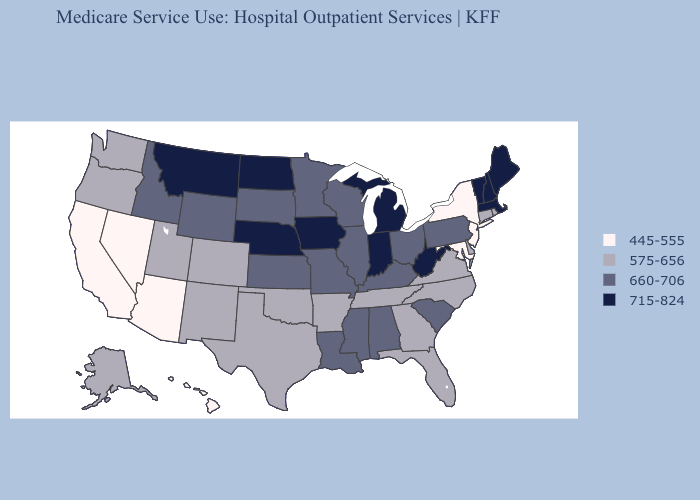Does Wyoming have the highest value in the USA?
Write a very short answer. No. Name the states that have a value in the range 575-656?
Quick response, please. Alaska, Arkansas, Colorado, Connecticut, Delaware, Florida, Georgia, New Mexico, North Carolina, Oklahoma, Oregon, Rhode Island, Tennessee, Texas, Utah, Virginia, Washington. Does West Virginia have the highest value in the South?
Concise answer only. Yes. What is the value of Utah?
Write a very short answer. 575-656. What is the value of Vermont?
Keep it brief. 715-824. Among the states that border Washington , which have the highest value?
Answer briefly. Idaho. What is the value of Wisconsin?
Be succinct. 660-706. What is the lowest value in states that border West Virginia?
Write a very short answer. 445-555. Name the states that have a value in the range 660-706?
Give a very brief answer. Alabama, Idaho, Illinois, Kansas, Kentucky, Louisiana, Minnesota, Mississippi, Missouri, Ohio, Pennsylvania, South Carolina, South Dakota, Wisconsin, Wyoming. Among the states that border Vermont , which have the lowest value?
Give a very brief answer. New York. Which states have the lowest value in the West?
Quick response, please. Arizona, California, Hawaii, Nevada. Name the states that have a value in the range 715-824?
Give a very brief answer. Indiana, Iowa, Maine, Massachusetts, Michigan, Montana, Nebraska, New Hampshire, North Dakota, Vermont, West Virginia. Among the states that border Missouri , which have the lowest value?
Answer briefly. Arkansas, Oklahoma, Tennessee. What is the value of Illinois?
Keep it brief. 660-706. Does Washington have a lower value than Arkansas?
Write a very short answer. No. 